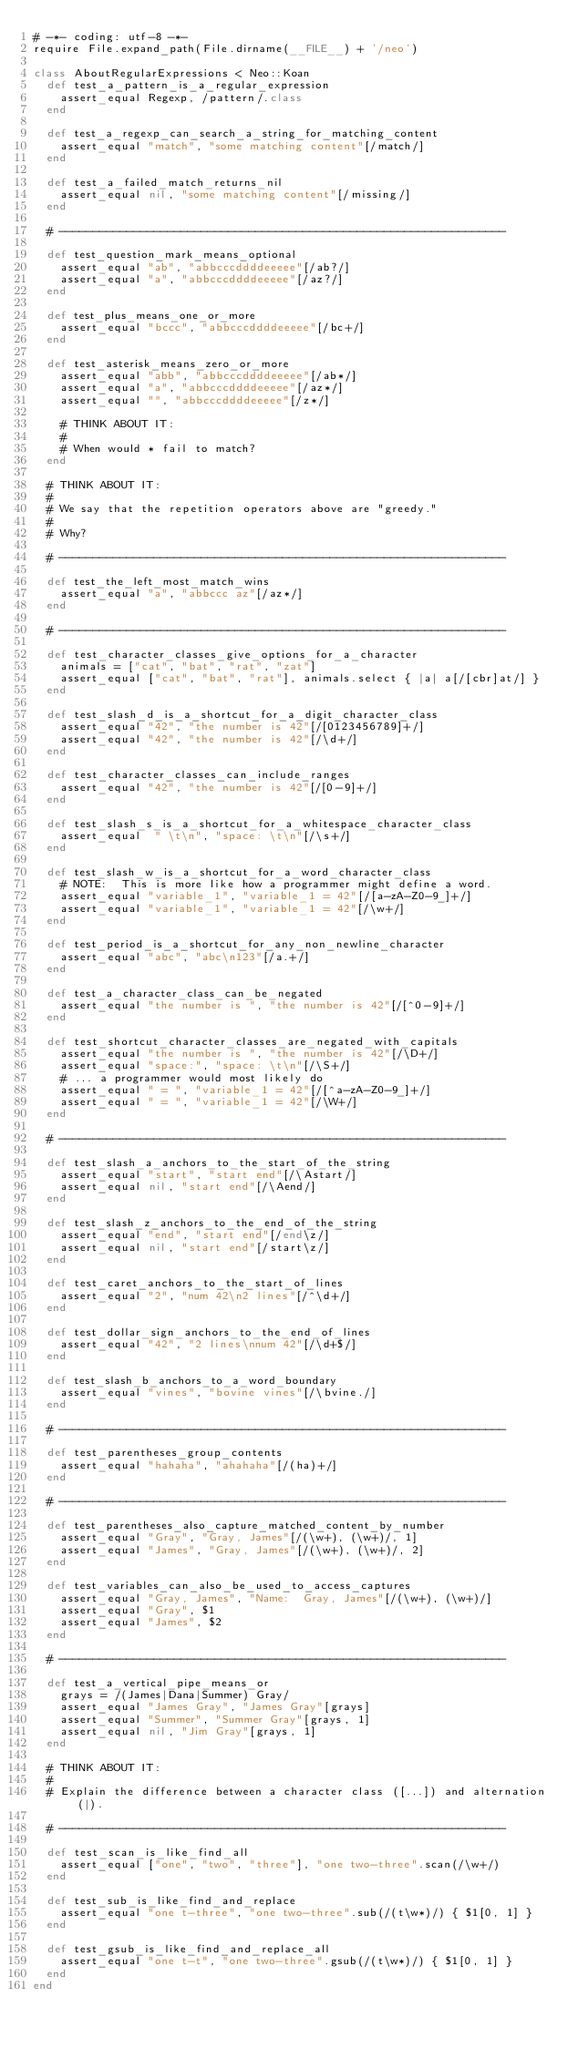Convert code to text. <code><loc_0><loc_0><loc_500><loc_500><_Ruby_># -*- coding: utf-8 -*-
require File.expand_path(File.dirname(__FILE__) + '/neo')

class AboutRegularExpressions < Neo::Koan
  def test_a_pattern_is_a_regular_expression
    assert_equal Regexp, /pattern/.class
  end

  def test_a_regexp_can_search_a_string_for_matching_content
    assert_equal "match", "some matching content"[/match/]
  end

  def test_a_failed_match_returns_nil
    assert_equal nil, "some matching content"[/missing/]
  end

  # ------------------------------------------------------------------

  def test_question_mark_means_optional
    assert_equal "ab", "abbcccddddeeeee"[/ab?/]
    assert_equal "a", "abbcccddddeeeee"[/az?/]
  end

  def test_plus_means_one_or_more
    assert_equal "bccc", "abbcccddddeeeee"[/bc+/]
  end

  def test_asterisk_means_zero_or_more
    assert_equal "abb", "abbcccddddeeeee"[/ab*/]
    assert_equal "a", "abbcccddddeeeee"[/az*/]
    assert_equal "", "abbcccddddeeeee"[/z*/]

    # THINK ABOUT IT:
    #
    # When would * fail to match?
  end

  # THINK ABOUT IT:
  #
  # We say that the repetition operators above are "greedy."
  #
  # Why?

  # ------------------------------------------------------------------

  def test_the_left_most_match_wins
    assert_equal "a", "abbccc az"[/az*/]
  end

  # ------------------------------------------------------------------

  def test_character_classes_give_options_for_a_character
    animals = ["cat", "bat", "rat", "zat"]
    assert_equal ["cat", "bat", "rat"], animals.select { |a| a[/[cbr]at/] }
  end

  def test_slash_d_is_a_shortcut_for_a_digit_character_class
    assert_equal "42", "the number is 42"[/[0123456789]+/]
    assert_equal "42", "the number is 42"[/\d+/]
  end

  def test_character_classes_can_include_ranges
    assert_equal "42", "the number is 42"[/[0-9]+/]
  end

  def test_slash_s_is_a_shortcut_for_a_whitespace_character_class
    assert_equal  " \t\n", "space: \t\n"[/\s+/]
  end

  def test_slash_w_is_a_shortcut_for_a_word_character_class
    # NOTE:  This is more like how a programmer might define a word.
    assert_equal "variable_1", "variable_1 = 42"[/[a-zA-Z0-9_]+/]
    assert_equal "variable_1", "variable_1 = 42"[/\w+/]
  end

  def test_period_is_a_shortcut_for_any_non_newline_character
    assert_equal "abc", "abc\n123"[/a.+/]
  end

  def test_a_character_class_can_be_negated
    assert_equal "the number is ", "the number is 42"[/[^0-9]+/]
  end

  def test_shortcut_character_classes_are_negated_with_capitals
    assert_equal "the number is ", "the number is 42"[/\D+/]
    assert_equal "space:", "space: \t\n"[/\S+/]
    # ... a programmer would most likely do
    assert_equal " = ", "variable_1 = 42"[/[^a-zA-Z0-9_]+/]
    assert_equal " = ", "variable_1 = 42"[/\W+/]
  end

  # ------------------------------------------------------------------

  def test_slash_a_anchors_to_the_start_of_the_string
    assert_equal "start", "start end"[/\Astart/]
    assert_equal nil, "start end"[/\Aend/]
  end

  def test_slash_z_anchors_to_the_end_of_the_string
    assert_equal "end", "start end"[/end\z/]
    assert_equal nil, "start end"[/start\z/]
  end

  def test_caret_anchors_to_the_start_of_lines
    assert_equal "2", "num 42\n2 lines"[/^\d+/]
  end

  def test_dollar_sign_anchors_to_the_end_of_lines
    assert_equal "42", "2 lines\nnum 42"[/\d+$/]
  end

  def test_slash_b_anchors_to_a_word_boundary
    assert_equal "vines", "bovine vines"[/\bvine./]
  end

  # ------------------------------------------------------------------

  def test_parentheses_group_contents
    assert_equal "hahaha", "ahahaha"[/(ha)+/]
  end

  # ------------------------------------------------------------------

  def test_parentheses_also_capture_matched_content_by_number
    assert_equal "Gray", "Gray, James"[/(\w+), (\w+)/, 1]
    assert_equal "James", "Gray, James"[/(\w+), (\w+)/, 2]
  end

  def test_variables_can_also_be_used_to_access_captures
    assert_equal "Gray, James", "Name:  Gray, James"[/(\w+), (\w+)/]
    assert_equal "Gray", $1
    assert_equal "James", $2
  end

  # ------------------------------------------------------------------

  def test_a_vertical_pipe_means_or
    grays = /(James|Dana|Summer) Gray/
    assert_equal "James Gray", "James Gray"[grays]
    assert_equal "Summer", "Summer Gray"[grays, 1]
    assert_equal nil, "Jim Gray"[grays, 1]
  end

  # THINK ABOUT IT:
  #
  # Explain the difference between a character class ([...]) and alternation (|).

  # ------------------------------------------------------------------

  def test_scan_is_like_find_all
    assert_equal ["one", "two", "three"], "one two-three".scan(/\w+/)
  end

  def test_sub_is_like_find_and_replace
    assert_equal "one t-three", "one two-three".sub(/(t\w*)/) { $1[0, 1] }
  end

  def test_gsub_is_like_find_and_replace_all
    assert_equal "one t-t", "one two-three".gsub(/(t\w*)/) { $1[0, 1] }
  end
end
</code> 